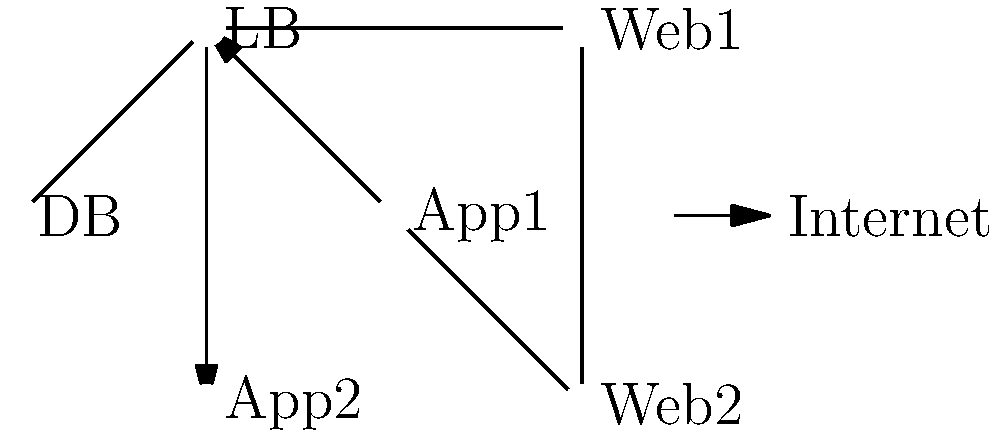Based on the network topology diagram provided, which component should be scaled horizontally to improve the performance and reliability of the Moodle server infrastructure? To determine which component should be scaled horizontally, let's analyze the diagram and consider the requirements of a Moodle server infrastructure:

1. The diagram shows a typical three-tier architecture:
   - Database (DB) at the bottom
   - Application servers (App1 and App2) in the middle
   - Web servers (Web1 and Web2) at the top

2. Load Balancer (LB) is present, indicating that traffic distribution is already implemented.

3. We can see that there are already two instances each of the application servers and web servers, which suggests some level of horizontal scaling.

4. The database (DB) is shown as a single instance, which could become a bottleneck in high-traffic scenarios.

5. For Moodle, the database is crucial as it stores course content, user data, and activity logs. A single database instance can become a performance bottleneck and a single point of failure.

6. Horizontally scaling the database layer would involve implementing a database cluster or replication setup, which can:
   - Improve read performance by distributing queries across multiple nodes
   - Enhance reliability through redundancy
   - Allow for better handling of concurrent connections

7. While scaling other components (like adding more application or web servers) can also be beneficial, the database is often the most critical component to scale in a Moodle infrastructure due to the data-intensive nature of the platform.

Therefore, based on this analysis, the database (DB) component should be prioritized for horizontal scaling to improve the overall performance and reliability of the Moodle server infrastructure.
Answer: Database (DB) 